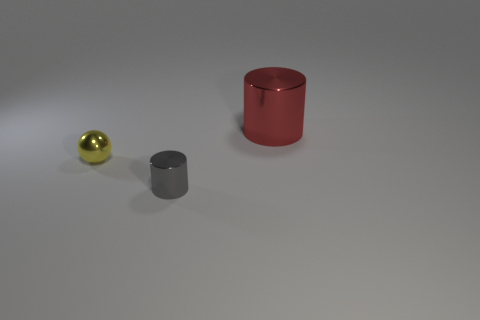Are there any other things that are the same shape as the yellow thing?
Make the answer very short. No. What number of purple objects are tiny shiny things or shiny cylinders?
Provide a short and direct response. 0. Are there any large blue spheres?
Make the answer very short. No. Are there any shiny cylinders that are behind the cylinder in front of the metal cylinder behind the yellow ball?
Provide a short and direct response. Yes. Is there anything else that has the same size as the red metal thing?
Make the answer very short. No. Is the shape of the big red object the same as the small metal object to the right of the small yellow object?
Keep it short and to the point. Yes. The shiny thing that is in front of the thing that is left of the tiny metal object that is in front of the yellow shiny ball is what color?
Your answer should be compact. Gray. How many things are either metallic objects to the right of the tiny metallic cylinder or metallic cylinders that are behind the gray metallic thing?
Your response must be concise. 1. Is the shape of the thing that is on the right side of the tiny gray shiny thing the same as  the small gray object?
Provide a short and direct response. Yes. Are there fewer small metal cylinders that are behind the sphere than tiny yellow balls?
Your answer should be compact. Yes. 